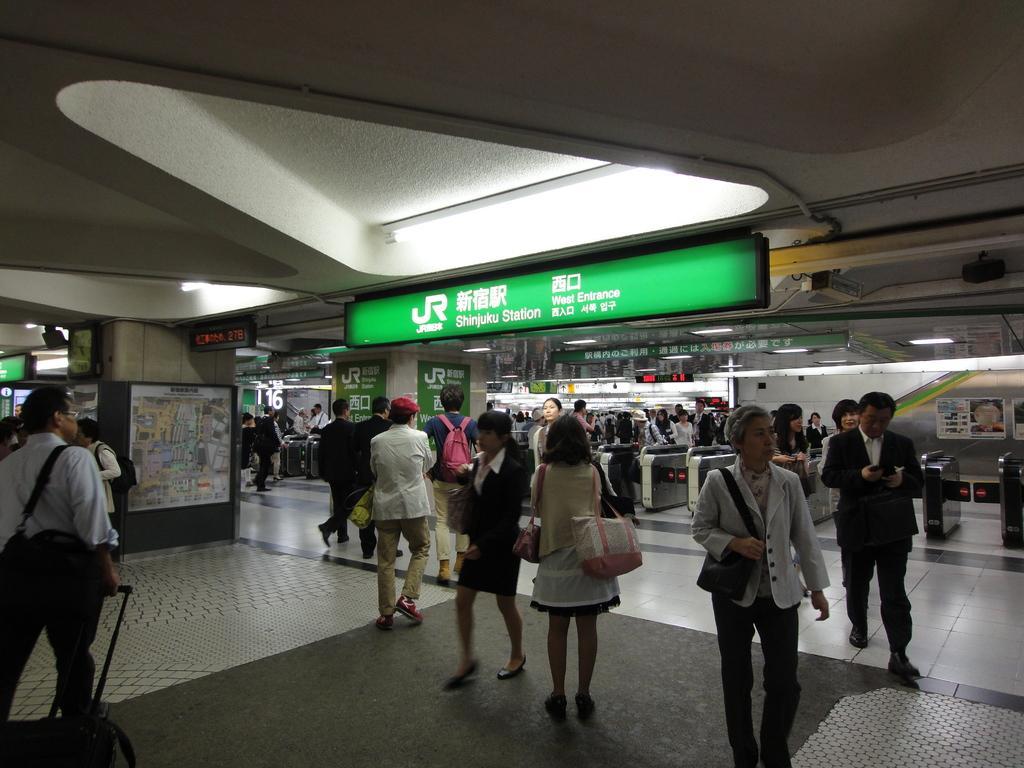Can you describe this image briefly? In the image there are many people standing and walking on the floor, this seems to be clicked in a mall, in the back there are stores and above there are lights over the ceiling. 